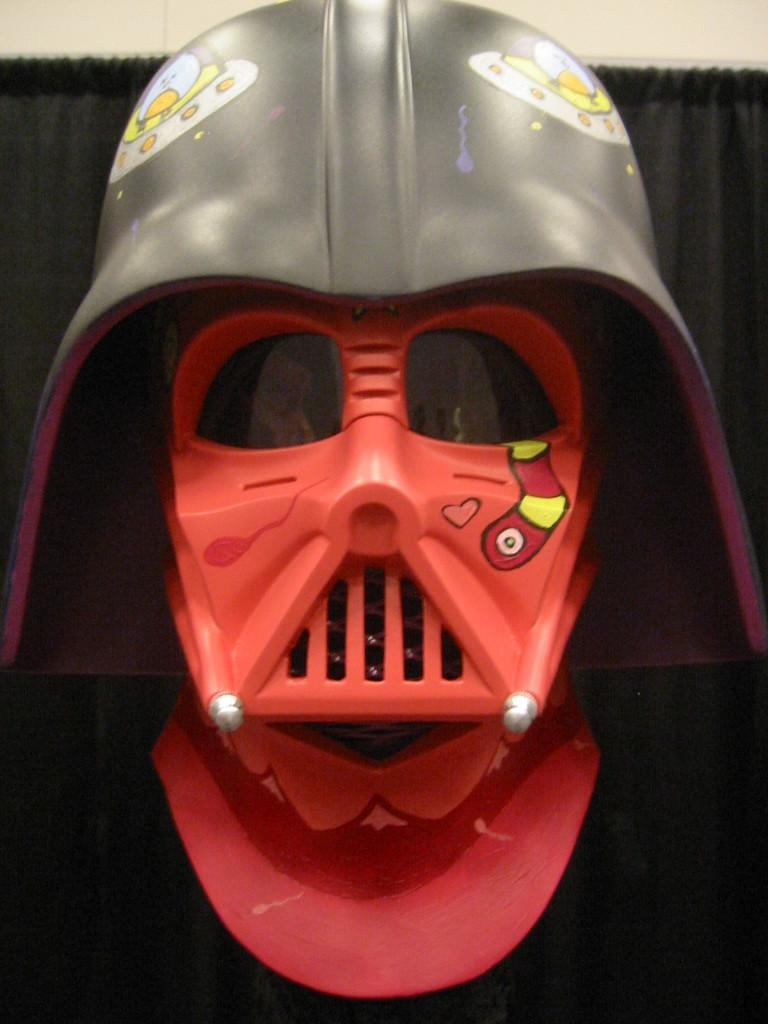What object is the main focus of the image? There is a mask in the image. Can you describe the colors of the mask? The mask is red and gray in color. What can be seen in the background of the image? There is a curtain in the background of the image. What color is the curtain? The curtain is black in color. What is the color of the wall in the background? The wall in the background is white in color. What type of work is being done on the addition to the house in the image? There is no addition to a house or any work being done in the image; it features a mask and a curtain in the background. 